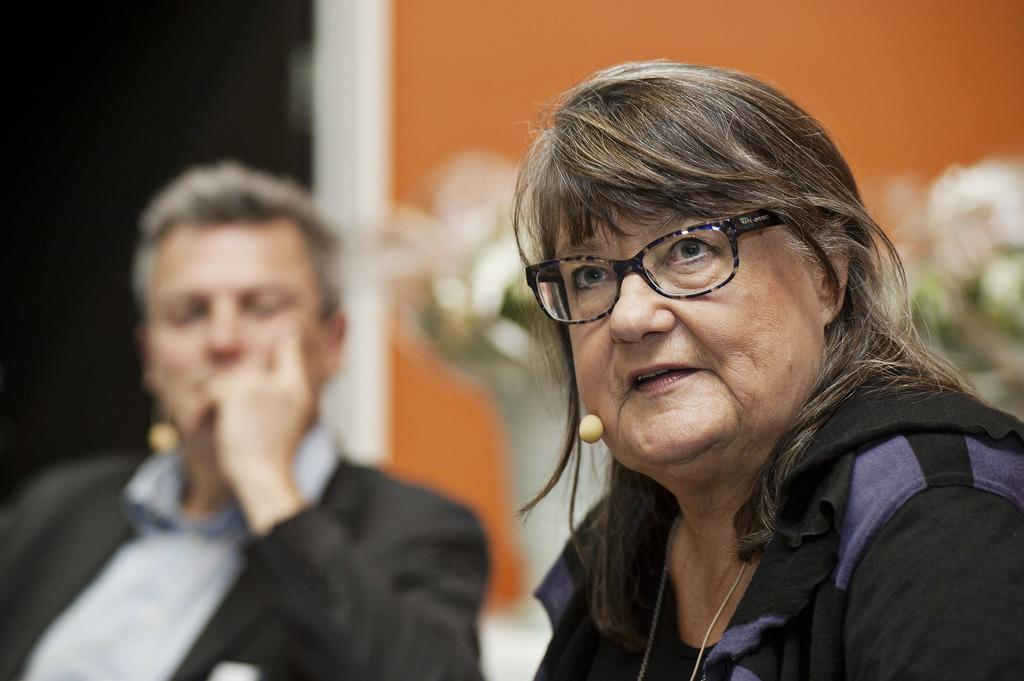What is the person in the image doing with the laptop? The person is typing on a laptop. Can you describe the person's activity in the image? The person is engaged in typing on a laptop. What might the person be working on or creating with the laptop? It is not possible to determine the specific task or project the person is working on from the image alone. What language is the person speaking while typing on the laptop? The image does not provide any information about the language being spoken, as it only shows the person typing on a laptop. Can you tell me how many hydrants are visible in the image? There are no hydrants present in the image; it only features a person typing on a laptop. Is the light in the room affecting the person's ability to type on the laptop? The image does not provide any information about the lighting conditions in the room, so it is not possible to determine if the light is affecting the person's ability to type on the laptop. 